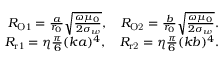<formula> <loc_0><loc_0><loc_500><loc_500>\begin{array} { r } { R _ { O 1 } = \frac { a } { r _ { 0 } } \sqrt { \frac { \omega \mu _ { 0 } } { 2 \sigma _ { w } } } , \quad R _ { O 2 } = \frac { b } { r _ { 0 } } \sqrt { \frac { \omega \mu _ { 0 } } { 2 \sigma _ { w } } } . } \\ { R _ { r 1 } = \eta \frac { \pi } { 6 } ( k a ) ^ { 4 } , \quad R _ { r 2 } = \eta \frac { \pi } { 6 } ( k b ) ^ { 4 } . } \end{array}</formula> 